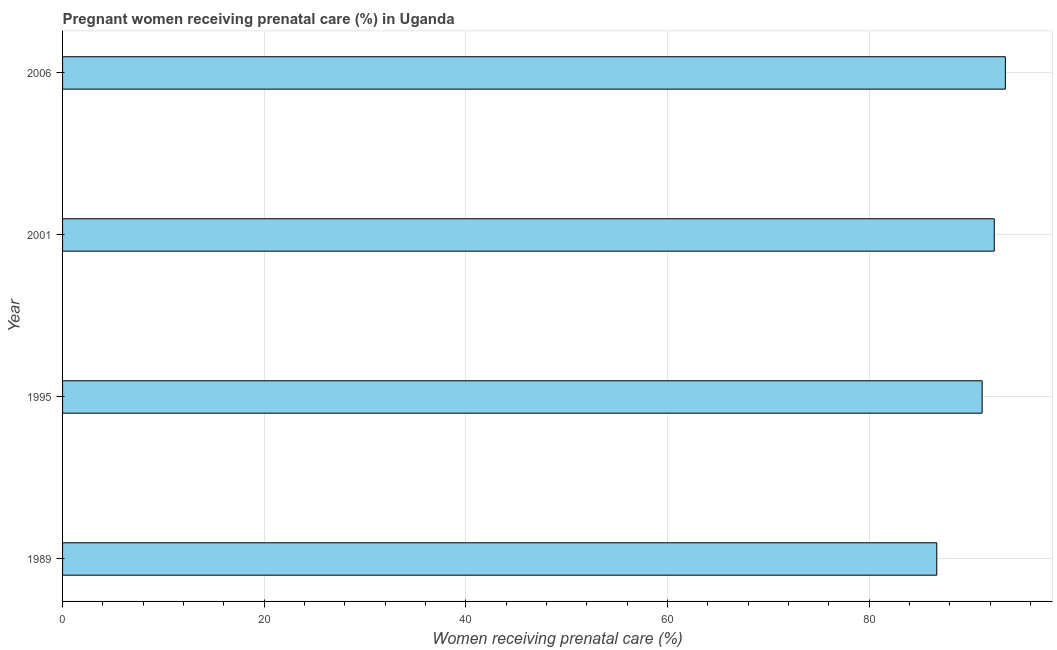Does the graph contain any zero values?
Your response must be concise. No. Does the graph contain grids?
Give a very brief answer. Yes. What is the title of the graph?
Give a very brief answer. Pregnant women receiving prenatal care (%) in Uganda. What is the label or title of the X-axis?
Offer a terse response. Women receiving prenatal care (%). What is the label or title of the Y-axis?
Offer a very short reply. Year. What is the percentage of pregnant women receiving prenatal care in 1995?
Provide a short and direct response. 91.2. Across all years, what is the maximum percentage of pregnant women receiving prenatal care?
Provide a succinct answer. 93.5. Across all years, what is the minimum percentage of pregnant women receiving prenatal care?
Ensure brevity in your answer.  86.7. In which year was the percentage of pregnant women receiving prenatal care maximum?
Offer a terse response. 2006. What is the sum of the percentage of pregnant women receiving prenatal care?
Your answer should be very brief. 363.8. What is the difference between the percentage of pregnant women receiving prenatal care in 2001 and 2006?
Your response must be concise. -1.1. What is the average percentage of pregnant women receiving prenatal care per year?
Your answer should be compact. 90.95. What is the median percentage of pregnant women receiving prenatal care?
Give a very brief answer. 91.8. What is the ratio of the percentage of pregnant women receiving prenatal care in 1989 to that in 2006?
Your response must be concise. 0.93. Is the percentage of pregnant women receiving prenatal care in 2001 less than that in 2006?
Give a very brief answer. Yes. What is the difference between the highest and the second highest percentage of pregnant women receiving prenatal care?
Offer a terse response. 1.1. How many bars are there?
Your response must be concise. 4. Are the values on the major ticks of X-axis written in scientific E-notation?
Offer a very short reply. No. What is the Women receiving prenatal care (%) of 1989?
Offer a terse response. 86.7. What is the Women receiving prenatal care (%) of 1995?
Offer a terse response. 91.2. What is the Women receiving prenatal care (%) of 2001?
Give a very brief answer. 92.4. What is the Women receiving prenatal care (%) in 2006?
Provide a succinct answer. 93.5. What is the difference between the Women receiving prenatal care (%) in 1989 and 2001?
Offer a very short reply. -5.7. What is the difference between the Women receiving prenatal care (%) in 1989 and 2006?
Your answer should be very brief. -6.8. What is the difference between the Women receiving prenatal care (%) in 1995 and 2006?
Your response must be concise. -2.3. What is the difference between the Women receiving prenatal care (%) in 2001 and 2006?
Offer a very short reply. -1.1. What is the ratio of the Women receiving prenatal care (%) in 1989 to that in 1995?
Provide a short and direct response. 0.95. What is the ratio of the Women receiving prenatal care (%) in 1989 to that in 2001?
Your answer should be very brief. 0.94. What is the ratio of the Women receiving prenatal care (%) in 1989 to that in 2006?
Give a very brief answer. 0.93. What is the ratio of the Women receiving prenatal care (%) in 1995 to that in 2006?
Keep it short and to the point. 0.97. What is the ratio of the Women receiving prenatal care (%) in 2001 to that in 2006?
Offer a terse response. 0.99. 